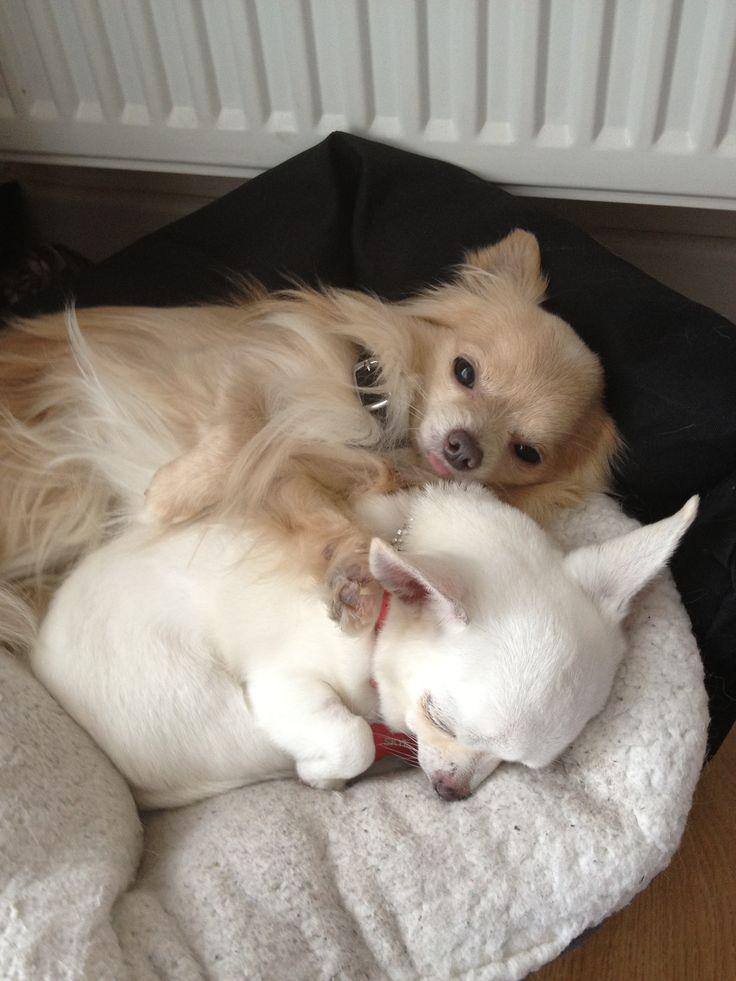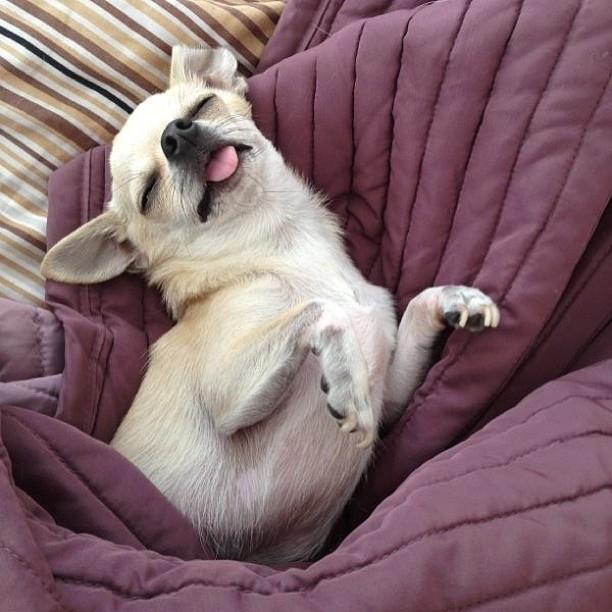The first image is the image on the left, the second image is the image on the right. Evaluate the accuracy of this statement regarding the images: "The left image shows two chihuahuas in sleeping poses side-by-side, and the right image shows one snoozing chihuahua on solid-colored fabric.". Is it true? Answer yes or no. Yes. The first image is the image on the left, the second image is the image on the right. Evaluate the accuracy of this statement regarding the images: "At least one chihuahua is sleeping on its back on a cozy blanket.". Is it true? Answer yes or no. Yes. 